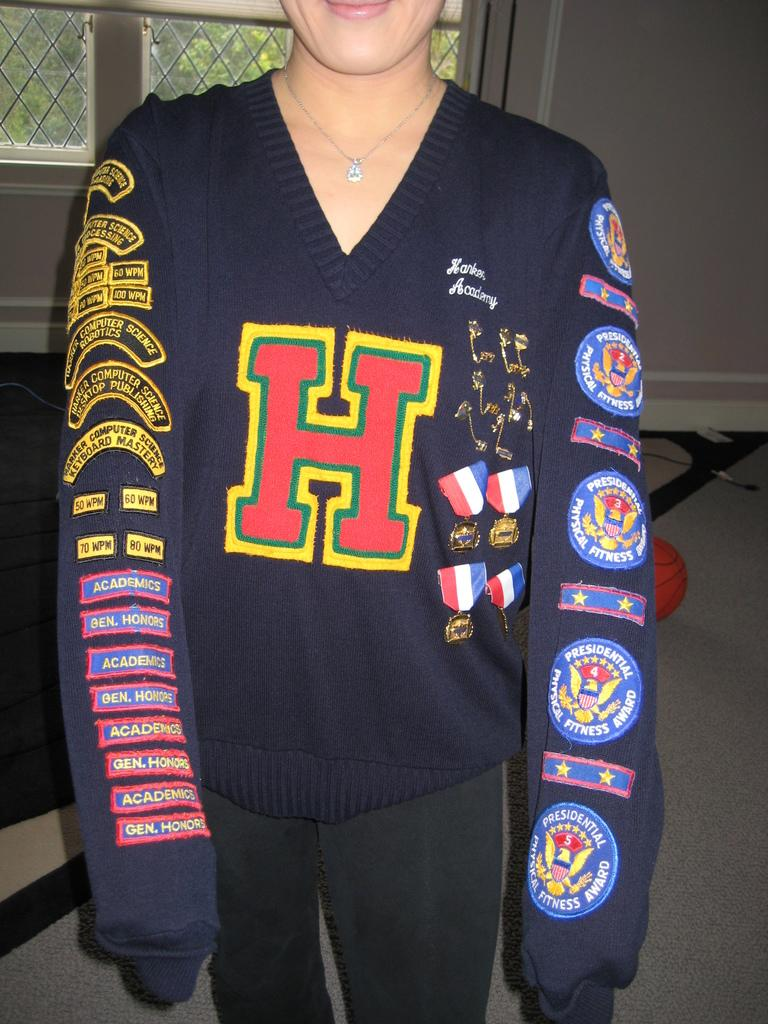<image>
Present a compact description of the photo's key features. The blue high school sweater is covered in patches for the presidential physical fitness award and academic honors and is emblazoned with a large letter H. 